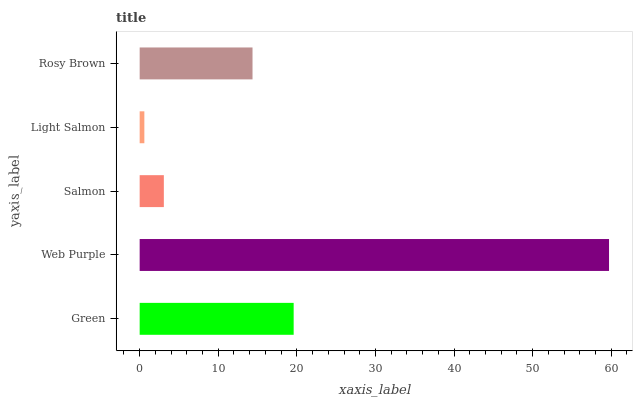Is Light Salmon the minimum?
Answer yes or no. Yes. Is Web Purple the maximum?
Answer yes or no. Yes. Is Salmon the minimum?
Answer yes or no. No. Is Salmon the maximum?
Answer yes or no. No. Is Web Purple greater than Salmon?
Answer yes or no. Yes. Is Salmon less than Web Purple?
Answer yes or no. Yes. Is Salmon greater than Web Purple?
Answer yes or no. No. Is Web Purple less than Salmon?
Answer yes or no. No. Is Rosy Brown the high median?
Answer yes or no. Yes. Is Rosy Brown the low median?
Answer yes or no. Yes. Is Salmon the high median?
Answer yes or no. No. Is Salmon the low median?
Answer yes or no. No. 